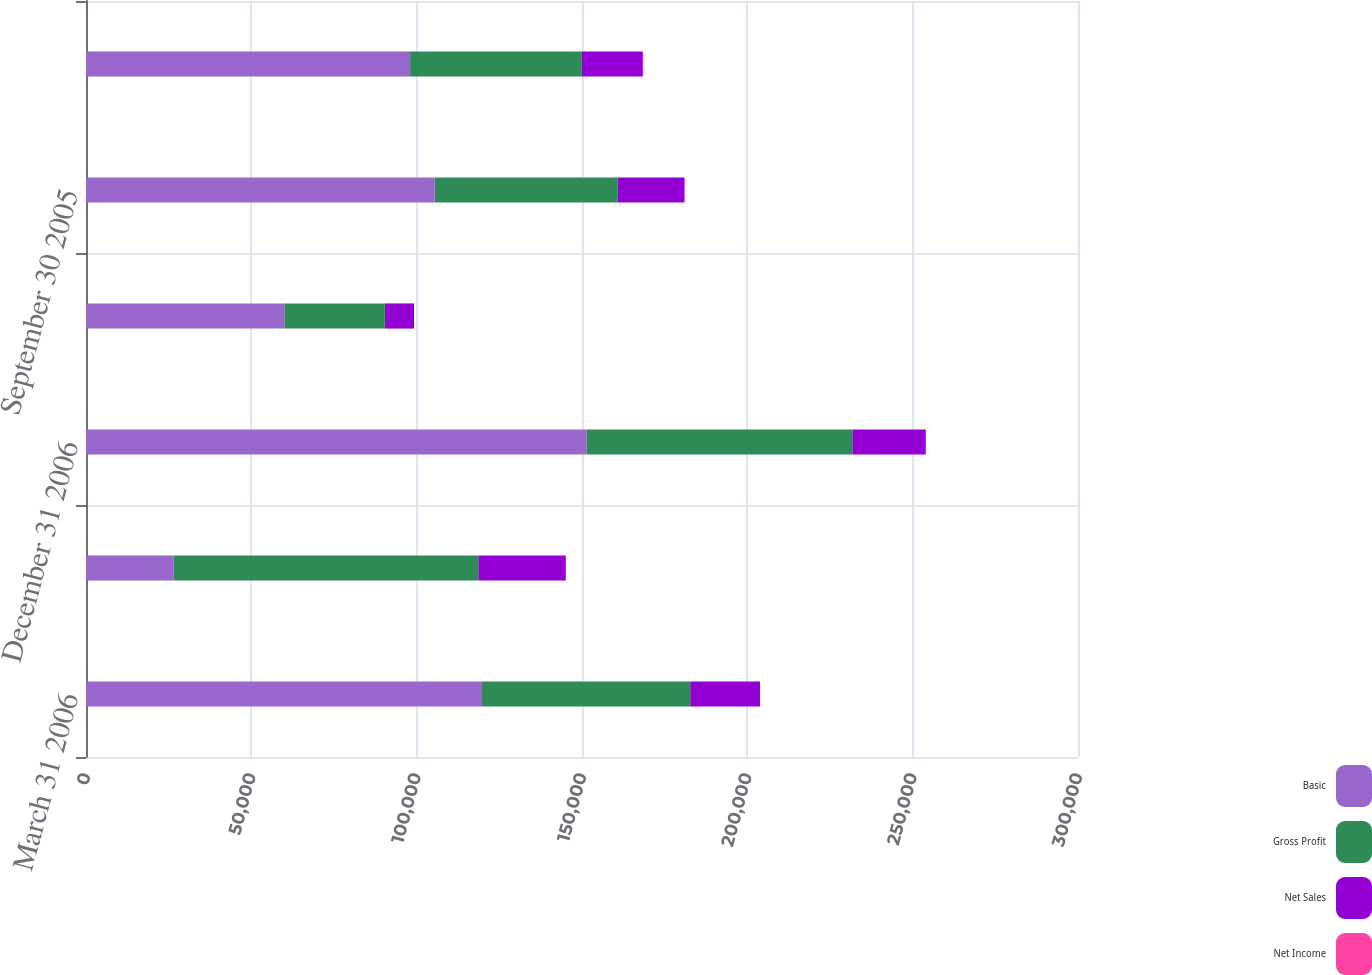<chart> <loc_0><loc_0><loc_500><loc_500><stacked_bar_chart><ecel><fcel>March 31 2006<fcel>September 30 2006<fcel>December 31 2006<fcel>March 31 2005<fcel>September 30 2005<fcel>December 31 2005<nl><fcel>Basic<fcel>119746<fcel>26457<fcel>151344<fcel>60014<fcel>105421<fcel>98010<nl><fcel>Gross Profit<fcel>62998<fcel>92184<fcel>80422<fcel>30329<fcel>55344<fcel>51943<nl><fcel>Net Sales<fcel>21091<fcel>26457<fcel>22201<fcel>8845<fcel>20245<fcel>18439<nl><fcel>Net Income<fcel>0.23<fcel>0.29<fcel>0.26<fcel>0.1<fcel>0.23<fcel>0.21<nl></chart> 